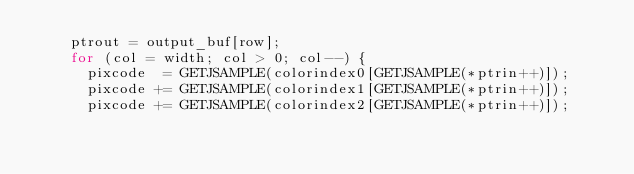<code> <loc_0><loc_0><loc_500><loc_500><_C_>    ptrout = output_buf[row];
    for (col = width; col > 0; col--) {
      pixcode  = GETJSAMPLE(colorindex0[GETJSAMPLE(*ptrin++)]);
      pixcode += GETJSAMPLE(colorindex1[GETJSAMPLE(*ptrin++)]);
      pixcode += GETJSAMPLE(colorindex2[GETJSAMPLE(*ptrin++)]);</code> 